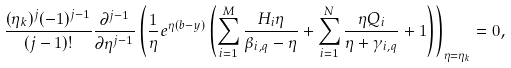Convert formula to latex. <formula><loc_0><loc_0><loc_500><loc_500>\frac { ( \eta _ { k } ) ^ { j } ( - 1 ) ^ { j - 1 } } { ( j - 1 ) ! } \frac { \partial ^ { j - 1 } } { \partial \eta ^ { j - 1 } } \left ( \frac { 1 } { \eta } e ^ { \eta ( b - y ) } \left ( \sum _ { i = 1 } ^ { M } \frac { H _ { i } \eta } { \beta _ { i , q } - \eta } + \sum _ { i = 1 } ^ { N } \frac { \eta Q _ { i } } { \eta + \gamma _ { i , q } } + 1 \right ) \right ) _ { \eta = \eta _ { k } } = 0 ,</formula> 